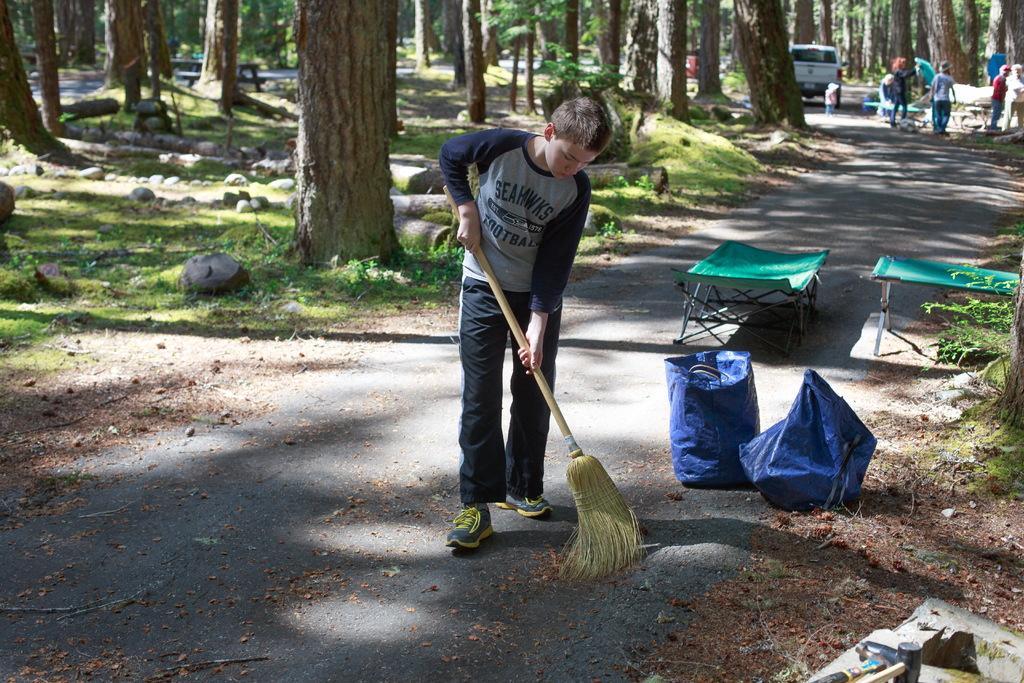In one or two sentences, can you explain what this image depicts? In the image we can see a boy standing, wearing clothes, shoes and holding a broomstick in his hands. Behind the boy there are other people wearing clothes. Here we can see the road, dry leaves and grass. Here we can see stones and trees. 